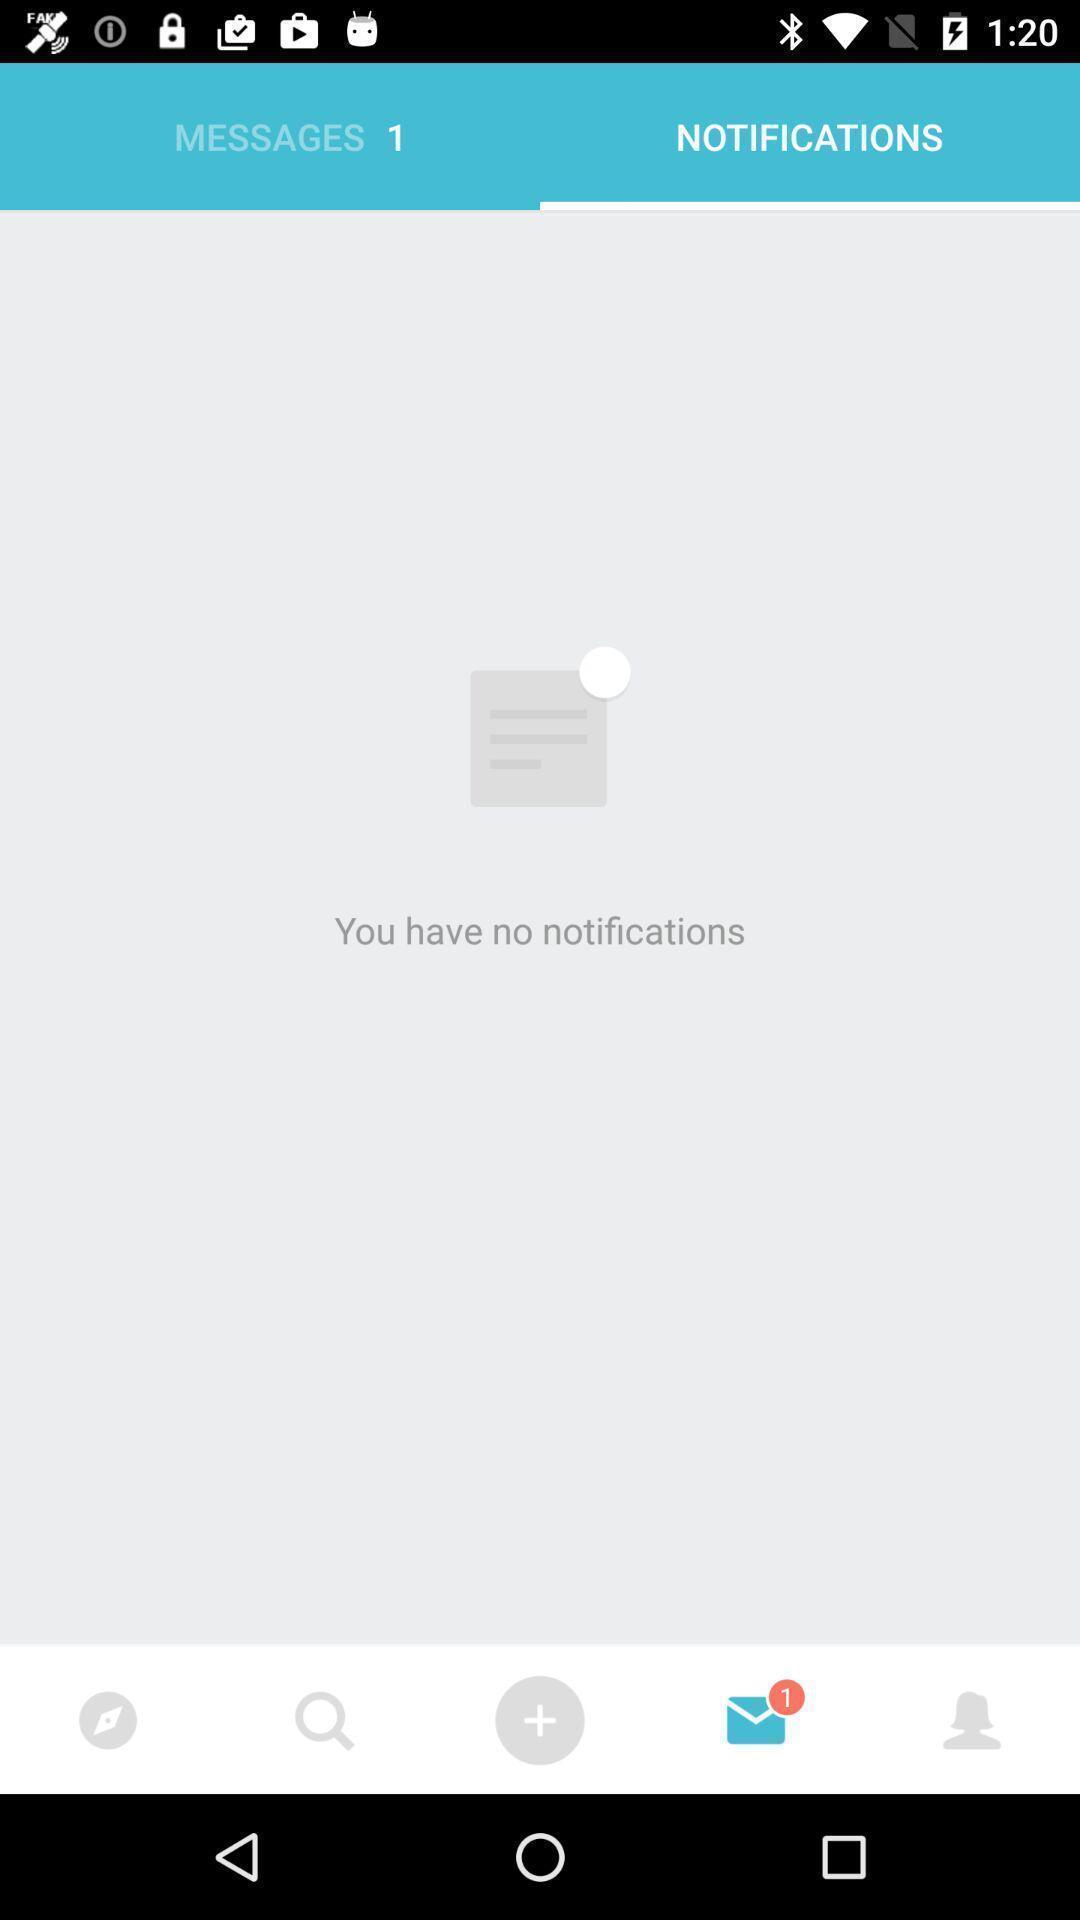Give me a summary of this screen capture. Screen displaying of no notification available in chatting application. 